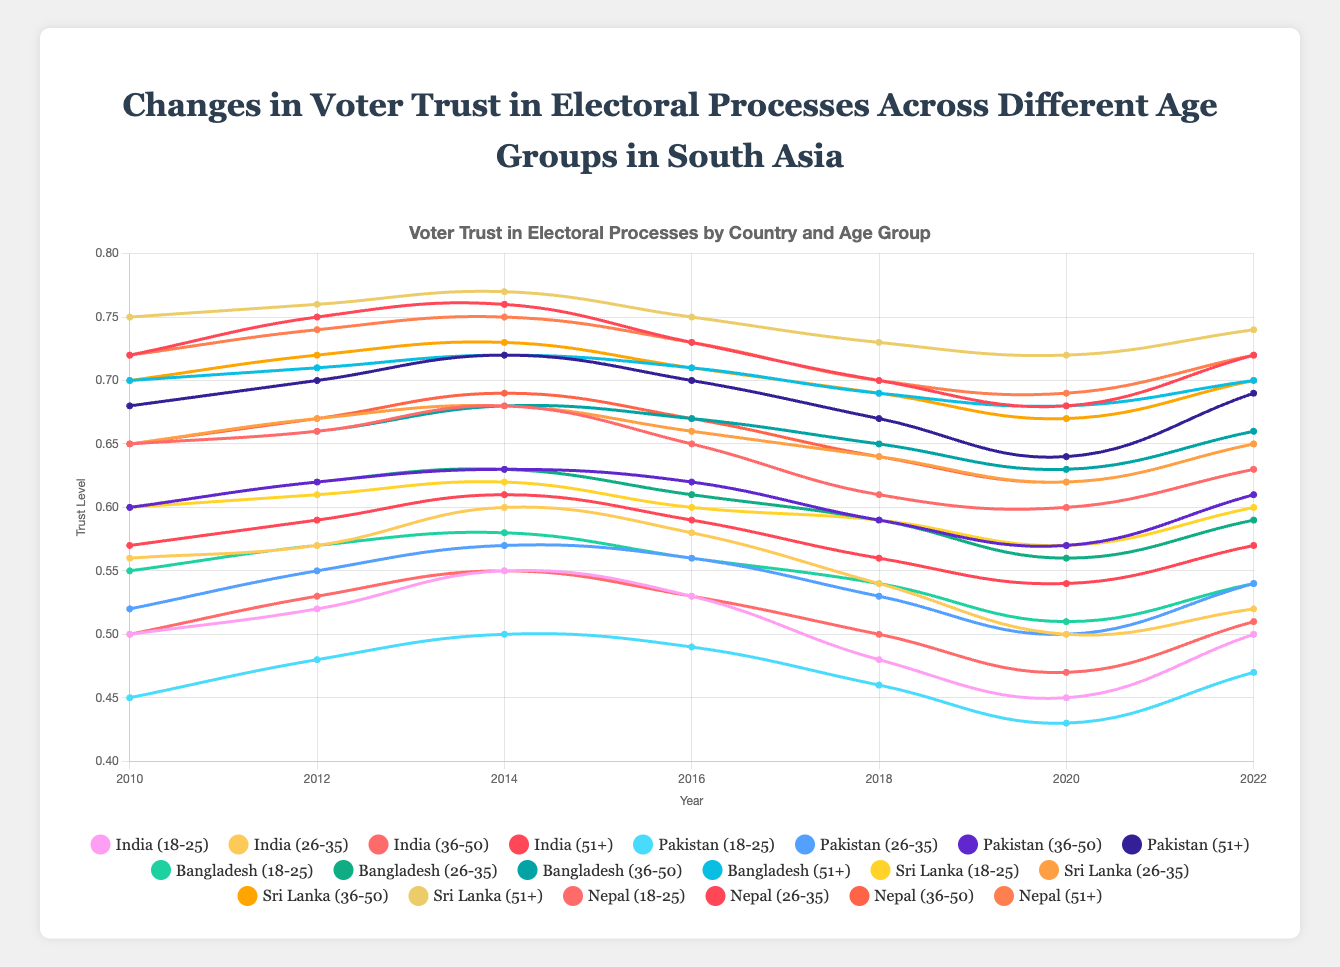What is the overall trend in trust levels among the age group 18-25 in India from 2010 to 2022? From the figure, observe the trend line for the age group 18-25 in India. Starting at 0.50 in 2010, it peaks at 0.55 in 2014, dips to 0.45 in 2020, and rises again to 0.50 by 2022. Thus, overall, it starts and ends at 0.50 with a dip and rise in between.
Answer: Stable with fluctuations Which country shows the highest voter trust level in the age group 51+ in 2022? Check the figure to find the height of the trust level lines for the age group 51+ in the year 2022 across all countries. Sri Lanka's line ends the highest at 0.74 in 2022.
Answer: Sri Lanka In 2018, which age group in Pakistan shows the lowest voter trust level? Refer to the trust level lines for Pakistan in the year 2018. The age group 18-25 has the lowest trust level of 0.46.
Answer: 18-25 Which age group had the most significant decrease in trust levels in India between 2016 and 2018? Observe the change between 2016 and 2018 for all age groups in India. The age group 18-25 saw a decrease from 0.53 to 0.48. Calculate: 0.53 - 0.48 = 0.05. Comparing all age groups, this is the largest decrease.
Answer: 18-25 Compare the voter trust levels of the 36-50 age group in Nepal and Bangladesh in 2020. Which country has the higher value? By looking at the trust level lines for the 36-50 age group in 2020, Nepal has 0.62 and Bangladesh has 0.63. Bangladesh is higher.
Answer: Bangladesh What is the average trust level of the age group 26-35 in Nepal over the years 2010, 2012, and 2014? Sum the trust levels for the chosen age group and years: 0.57 (2010) + 0.59 (2012) + 0.61 (2014) = 1.77. Divide by the number of years: 1.77 / 3 = 0.59.
Answer: 0.59 Considering the 18-25 age group, which country shows an overall increasing trend from 2010 to 2022? Compare the trend lines for each country for the 18-25 age group from 2010 to 2022. Only Bangladesh starts at 0.55 and ends at 0.54, showing fluctuations but not an overall increase. No country shows an overall increasing trend.
Answer: None Which age group in Sri Lanka demonstrated the most minor change in voter trust levels from 2010 to 2022? Calculate changes in trust levels for each age group in Sri Lanka from 2010 to 2022: 18-25 (0.60 to 0.60 = 0.00), 26-35 (0.65 to 0.65 = 0.00), 36-50 (0.70 to 0.70 = 0.00), 51+ (0.75 to 0.74 = 0.01). The 18-25, 26-35, and 36-50 groups all show the least change of 0.00.
Answer: 18-25, 26-35, 36-50 Which country shows the highest variance in voter trust levels for the 26-35 age group over the years? Calculate the variance for the 26-35 age group trust levels across the years for each country. India ([0.56, 0.57, 0.60, 0.58, 0.54, 0.50, 0.52]) has the highest variation.
Answer: India 